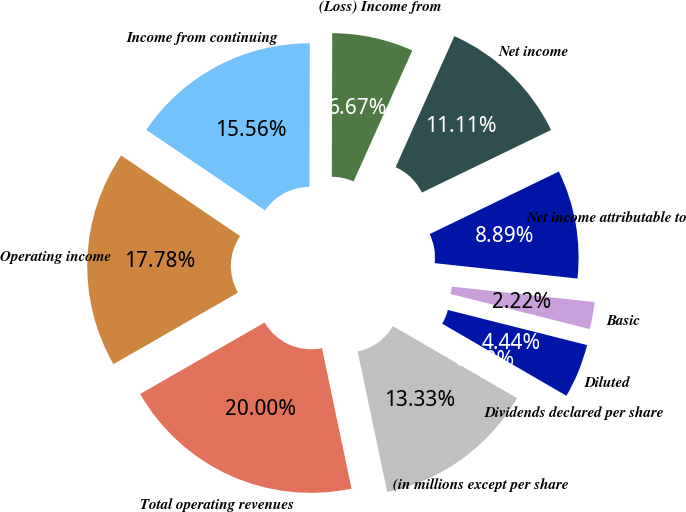Convert chart to OTSL. <chart><loc_0><loc_0><loc_500><loc_500><pie_chart><fcel>(in millions except per share<fcel>Total operating revenues<fcel>Operating income<fcel>Income from continuing<fcel>(Loss) Income from<fcel>Net income<fcel>Net income attributable to<fcel>Basic<fcel>Diluted<fcel>Dividends declared per share<nl><fcel>13.33%<fcel>20.0%<fcel>17.78%<fcel>15.56%<fcel>6.67%<fcel>11.11%<fcel>8.89%<fcel>2.22%<fcel>4.44%<fcel>0.0%<nl></chart> 